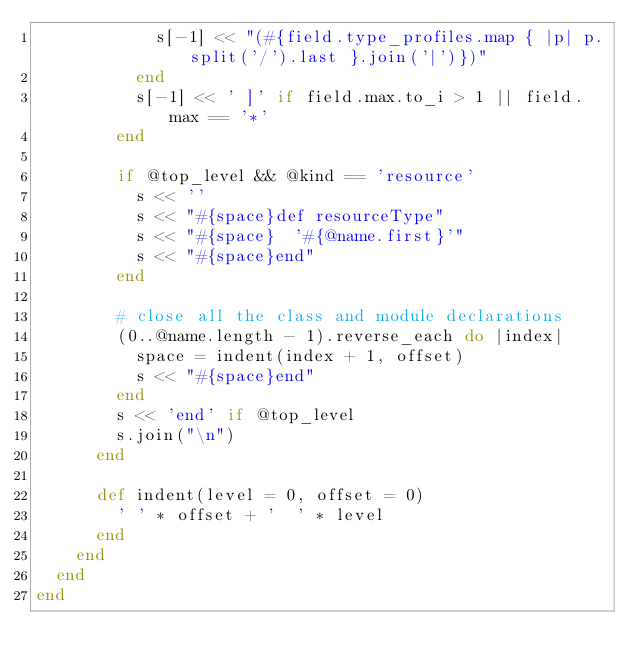<code> <loc_0><loc_0><loc_500><loc_500><_Ruby_>            s[-1] << "(#{field.type_profiles.map { |p| p.split('/').last }.join('|')})"
          end
          s[-1] << ' ]' if field.max.to_i > 1 || field.max == '*'
        end

        if @top_level && @kind == 'resource'
          s << ''
          s << "#{space}def resourceType"
          s << "#{space}  '#{@name.first}'"
          s << "#{space}end"
        end

        # close all the class and module declarations
        (0..@name.length - 1).reverse_each do |index|
          space = indent(index + 1, offset)
          s << "#{space}end"
        end
        s << 'end' if @top_level
        s.join("\n")
      end

      def indent(level = 0, offset = 0)
        ' ' * offset + '  ' * level
      end
    end
  end
end
</code> 